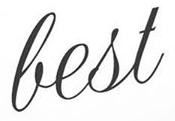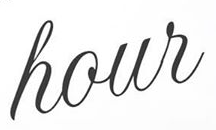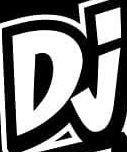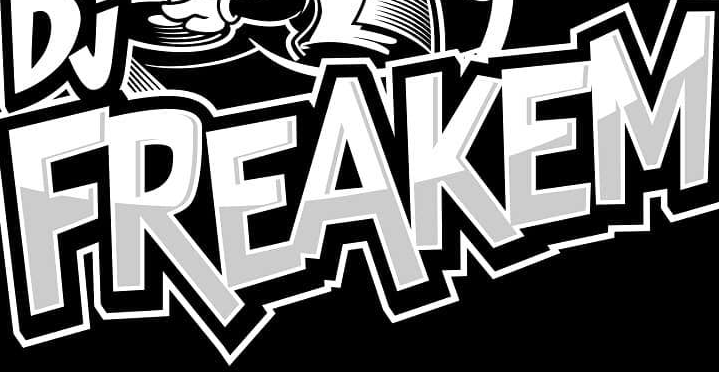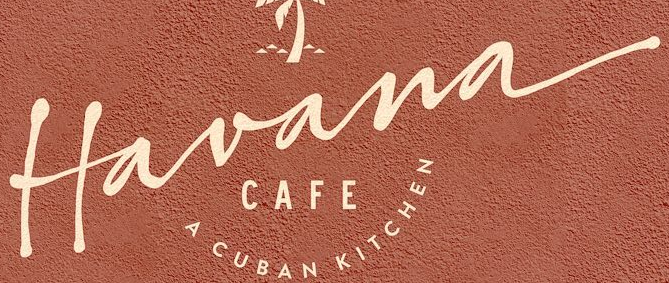Identify the words shown in these images in order, separated by a semicolon. best; hour; Dj; FREAKEM; Havana 